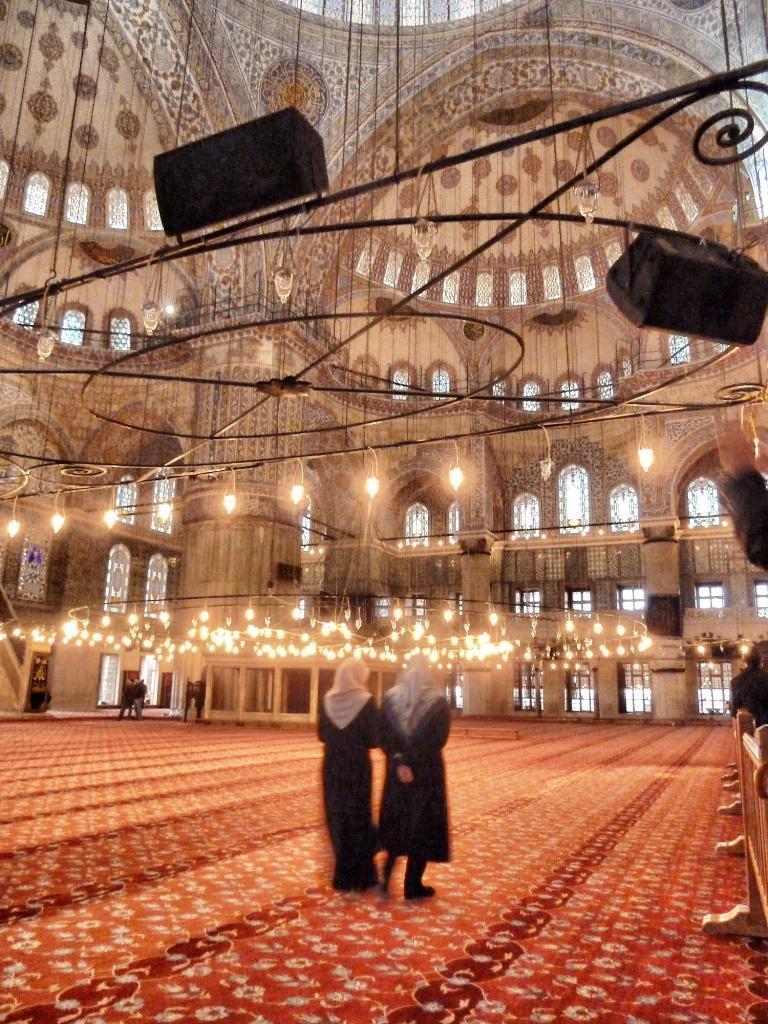How would you summarize this image in a sentence or two? In this image we can see these two persons are standing on the floor. Here we can see ceiling lights, some objects, wooden benches and the ceiling. 